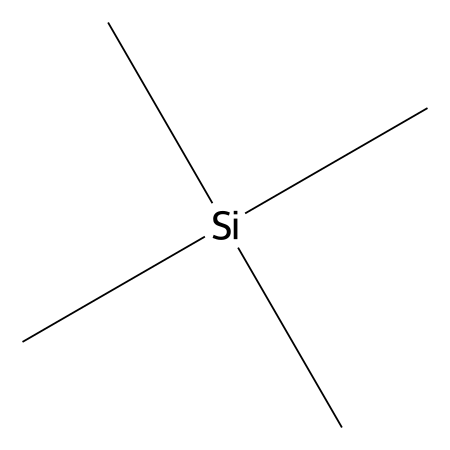How many carbon atoms are in tetramethylsilane? By analyzing the provided SMILES representation, "C[Si](C)(C)C", we see there are four instances of "C" which indicates there are four carbon atoms attached to the silicon atom.
Answer: four What is the central atom in tetramethylsilane? The central atom is indicated by "[Si]" in the SMILES notation, which corresponds to a silicon atom that is connected to the carbon atoms.
Answer: silicon How many hydrogen atoms are bonded to the central silicon atom? Each carbon (four in total) in the structure is bonded to three hydrogen atoms. Therefore, the total number of hydrogen atoms is 4 carbons × 3 hydrogens = 12 hydrogen atoms.
Answer: twelve What type of compound is tetramethylsilane classified as? Tetramethylsilane is classified as an organosilicon compound, which is characterized by having silicon-carbon bonds along with organic groups.
Answer: organosilicon What is the overall molecular formula for tetramethylsilane? From the analysis of the structure showing 4 carbon atoms, 12 hydrogen atoms, and 1 silicon atom, we can derive the molecular formula as C4H12Si.
Answer: C4H12Si Why do silanes typically have a tetrahedral geometry around the silicon atom? The tetrahedral geometry is caused by the sp3 hybridization of the silicon atom. Each of the four substituents (in this case, the methyl groups) requires four equivalent bonds around the silicon, leading to a tetrahedral arrangement.
Answer: tetrahedral What functional group does tetramethylsilane represent in organic silanes? The functional group represented in tetramethylsilane is the silane functional group, characterized by a silicon atom bonded to organic hydrocarbon groups (like methyl groups).
Answer: silane 